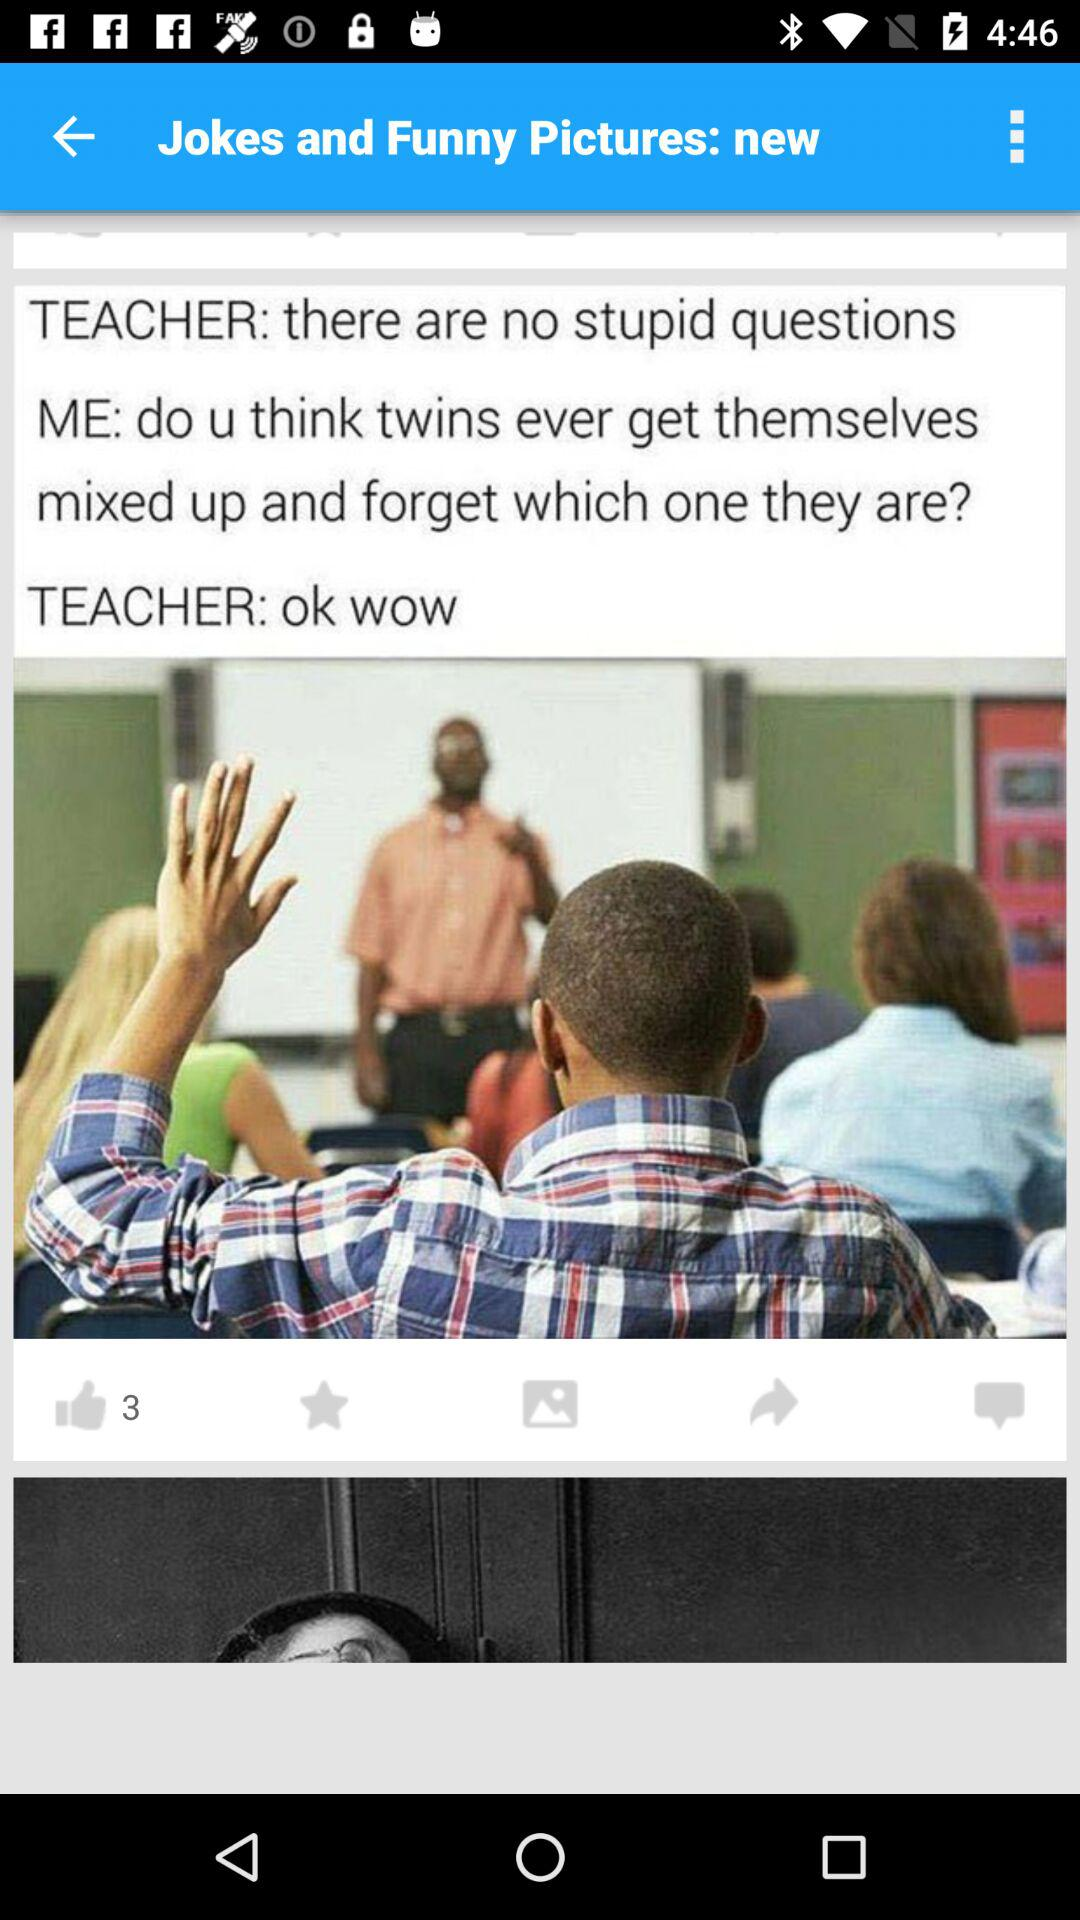How many likes does this post get? This post got 3 likes. 